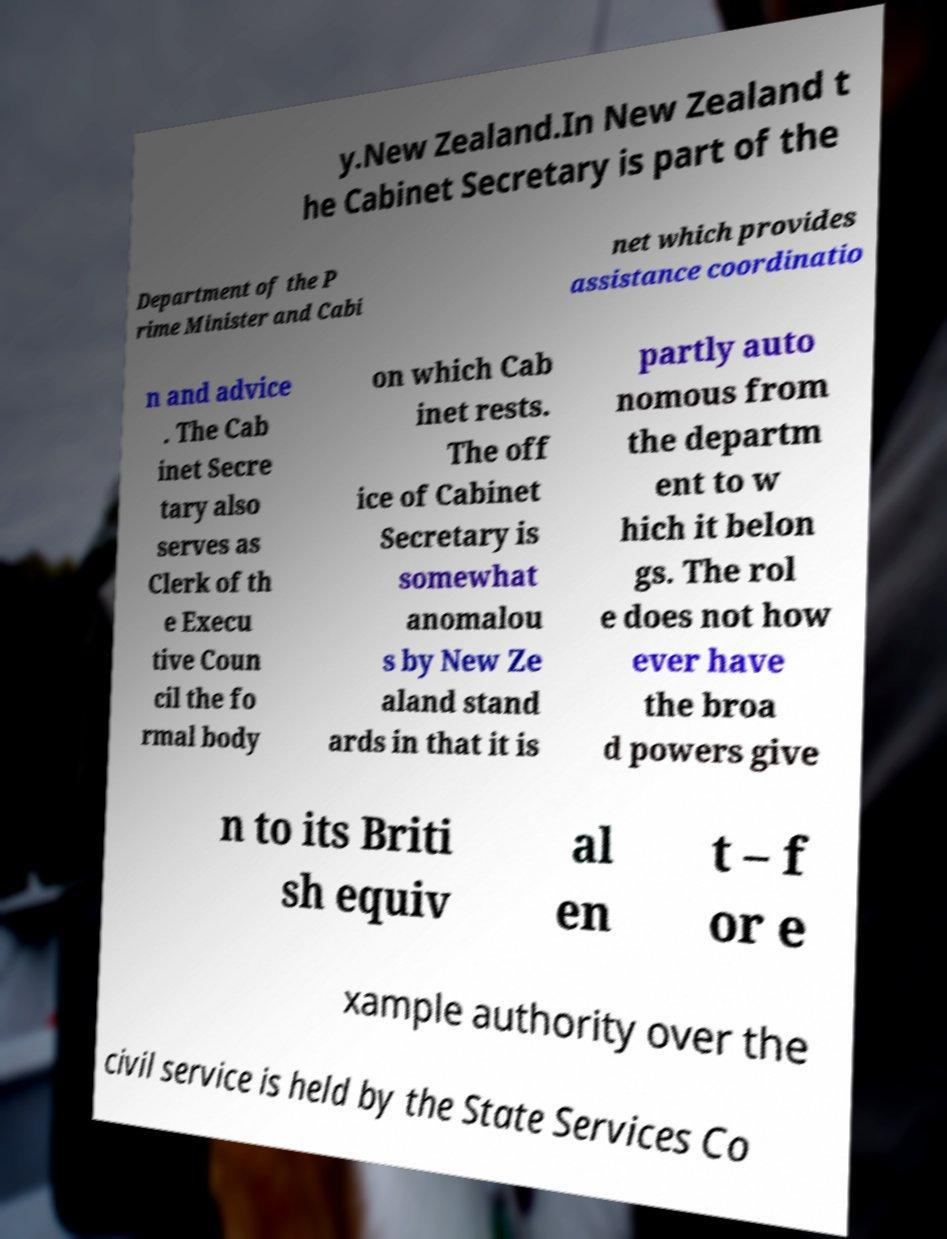Can you read and provide the text displayed in the image?This photo seems to have some interesting text. Can you extract and type it out for me? y.New Zealand.In New Zealand t he Cabinet Secretary is part of the Department of the P rime Minister and Cabi net which provides assistance coordinatio n and advice . The Cab inet Secre tary also serves as Clerk of th e Execu tive Coun cil the fo rmal body on which Cab inet rests. The off ice of Cabinet Secretary is somewhat anomalou s by New Ze aland stand ards in that it is partly auto nomous from the departm ent to w hich it belon gs. The rol e does not how ever have the broa d powers give n to its Briti sh equiv al en t – f or e xample authority over the civil service is held by the State Services Co 